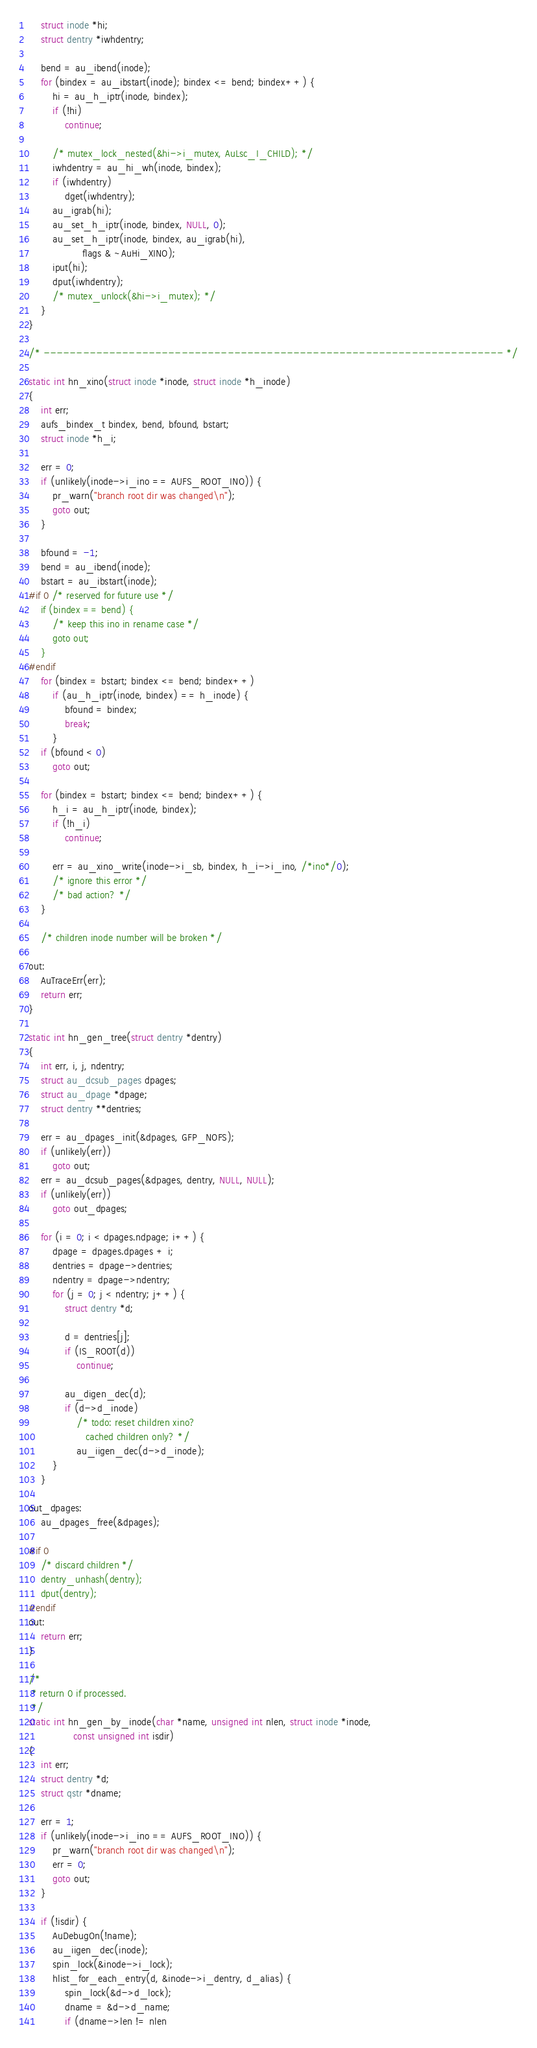<code> <loc_0><loc_0><loc_500><loc_500><_C_>	struct inode *hi;
	struct dentry *iwhdentry;

	bend = au_ibend(inode);
	for (bindex = au_ibstart(inode); bindex <= bend; bindex++) {
		hi = au_h_iptr(inode, bindex);
		if (!hi)
			continue;

		/* mutex_lock_nested(&hi->i_mutex, AuLsc_I_CHILD); */
		iwhdentry = au_hi_wh(inode, bindex);
		if (iwhdentry)
			dget(iwhdentry);
		au_igrab(hi);
		au_set_h_iptr(inode, bindex, NULL, 0);
		au_set_h_iptr(inode, bindex, au_igrab(hi),
			      flags & ~AuHi_XINO);
		iput(hi);
		dput(iwhdentry);
		/* mutex_unlock(&hi->i_mutex); */
	}
}

/* ---------------------------------------------------------------------- */

static int hn_xino(struct inode *inode, struct inode *h_inode)
{
	int err;
	aufs_bindex_t bindex, bend, bfound, bstart;
	struct inode *h_i;

	err = 0;
	if (unlikely(inode->i_ino == AUFS_ROOT_INO)) {
		pr_warn("branch root dir was changed\n");
		goto out;
	}

	bfound = -1;
	bend = au_ibend(inode);
	bstart = au_ibstart(inode);
#if 0 /* reserved for future use */
	if (bindex == bend) {
		/* keep this ino in rename case */
		goto out;
	}
#endif
	for (bindex = bstart; bindex <= bend; bindex++)
		if (au_h_iptr(inode, bindex) == h_inode) {
			bfound = bindex;
			break;
		}
	if (bfound < 0)
		goto out;

	for (bindex = bstart; bindex <= bend; bindex++) {
		h_i = au_h_iptr(inode, bindex);
		if (!h_i)
			continue;

		err = au_xino_write(inode->i_sb, bindex, h_i->i_ino, /*ino*/0);
		/* ignore this error */
		/* bad action? */
	}

	/* children inode number will be broken */

out:
	AuTraceErr(err);
	return err;
}

static int hn_gen_tree(struct dentry *dentry)
{
	int err, i, j, ndentry;
	struct au_dcsub_pages dpages;
	struct au_dpage *dpage;
	struct dentry **dentries;

	err = au_dpages_init(&dpages, GFP_NOFS);
	if (unlikely(err))
		goto out;
	err = au_dcsub_pages(&dpages, dentry, NULL, NULL);
	if (unlikely(err))
		goto out_dpages;

	for (i = 0; i < dpages.ndpage; i++) {
		dpage = dpages.dpages + i;
		dentries = dpage->dentries;
		ndentry = dpage->ndentry;
		for (j = 0; j < ndentry; j++) {
			struct dentry *d;

			d = dentries[j];
			if (IS_ROOT(d))
				continue;

			au_digen_dec(d);
			if (d->d_inode)
				/* todo: reset children xino?
				   cached children only? */
				au_iigen_dec(d->d_inode);
		}
	}

out_dpages:
	au_dpages_free(&dpages);

#if 0
	/* discard children */
	dentry_unhash(dentry);
	dput(dentry);
#endif
out:
	return err;
}

/*
 * return 0 if processed.
 */
static int hn_gen_by_inode(char *name, unsigned int nlen, struct inode *inode,
			   const unsigned int isdir)
{
	int err;
	struct dentry *d;
	struct qstr *dname;

	err = 1;
	if (unlikely(inode->i_ino == AUFS_ROOT_INO)) {
		pr_warn("branch root dir was changed\n");
		err = 0;
		goto out;
	}

	if (!isdir) {
		AuDebugOn(!name);
		au_iigen_dec(inode);
		spin_lock(&inode->i_lock);
		hlist_for_each_entry(d, &inode->i_dentry, d_alias) {
			spin_lock(&d->d_lock);
			dname = &d->d_name;
			if (dname->len != nlen</code> 